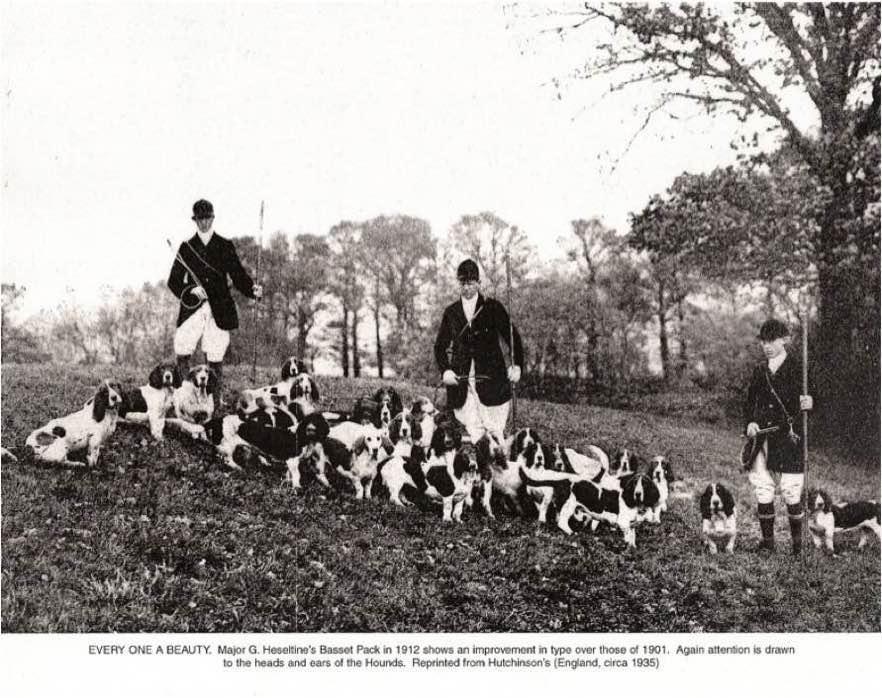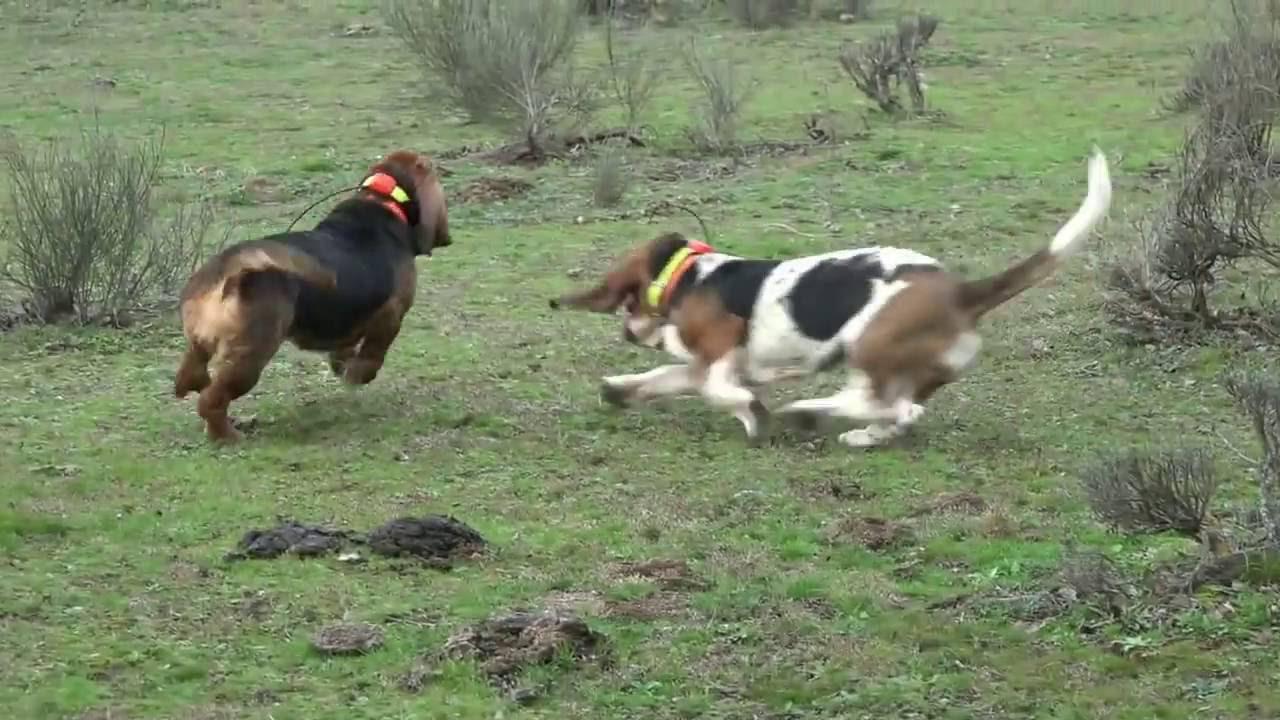The first image is the image on the left, the second image is the image on the right. Examine the images to the left and right. Is the description "There are no more than eight dogs in the right image." accurate? Answer yes or no. Yes. 